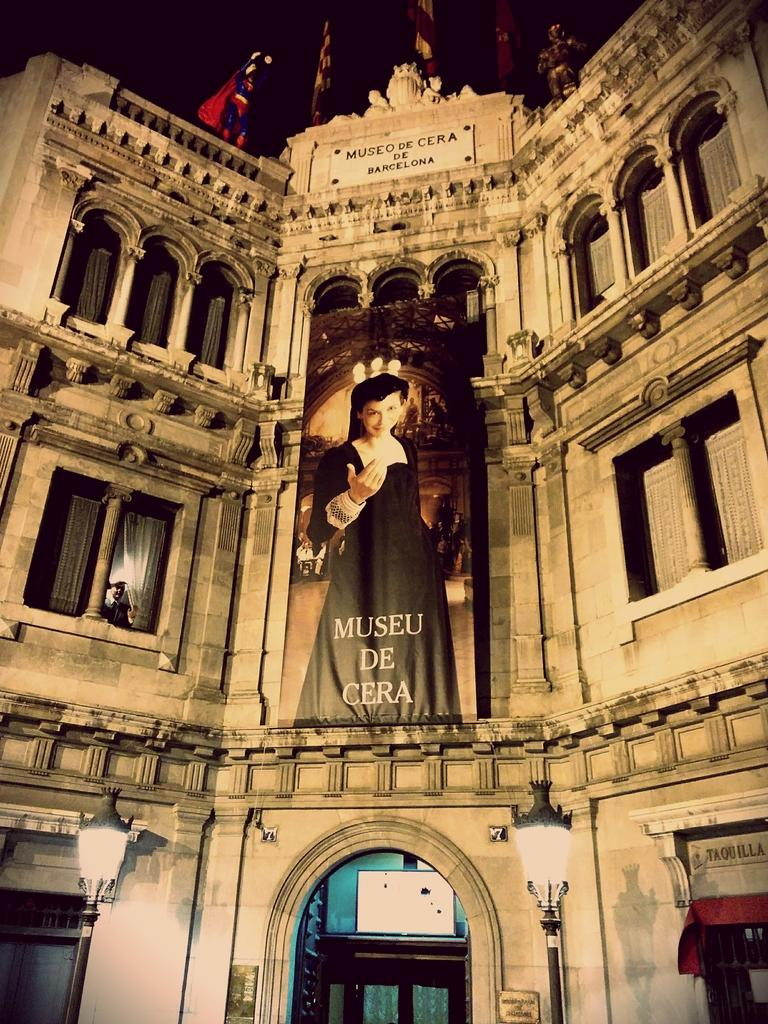What can be seen in the foreground of the image? There are lamp poles, a building, and a poster in the foreground of the image. What else is present in the foreground of the image? There are flags in the image. What is visible at the top side of the image? The sky is visible at the top side of the image. Can you tell me how many ducks are holding the parcel in the image? There are no ducks or parcels present in the image. What is the hand doing in the image? There is no hand visible in the image. 